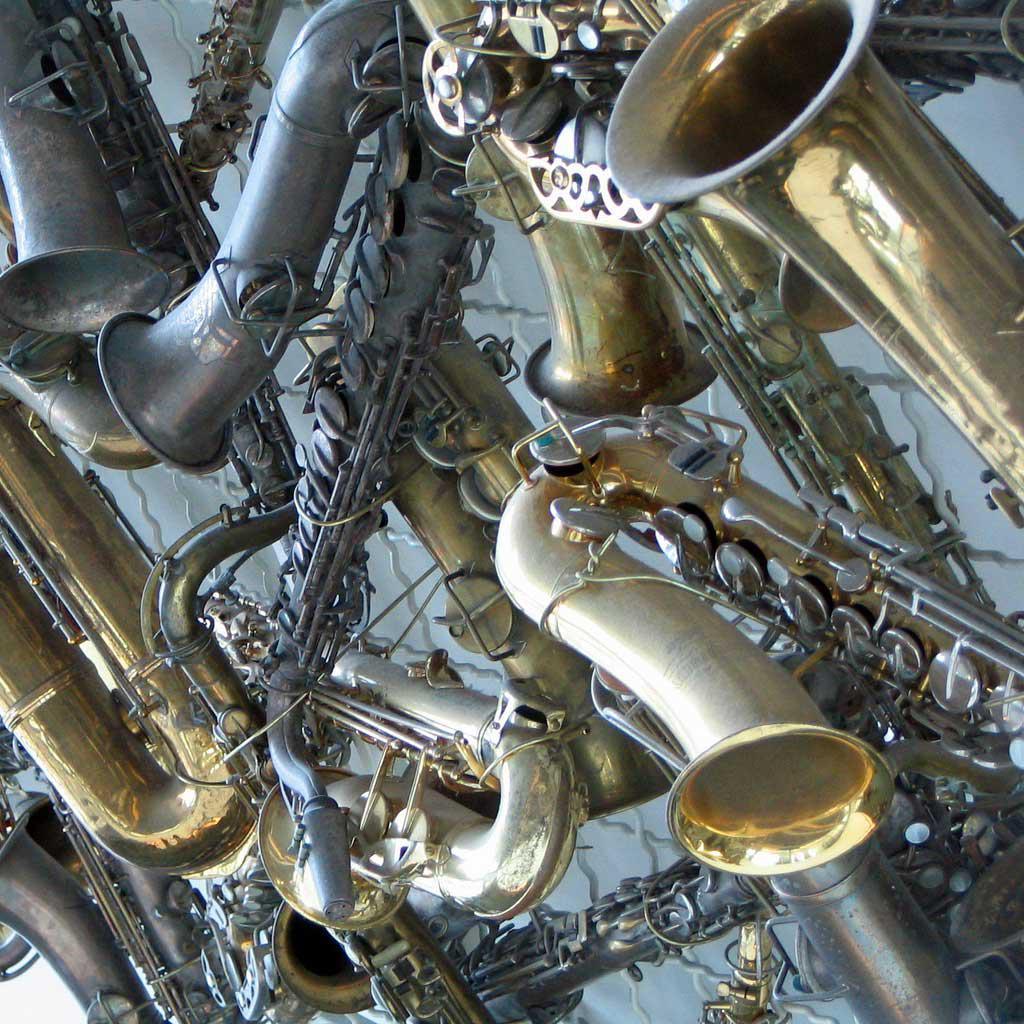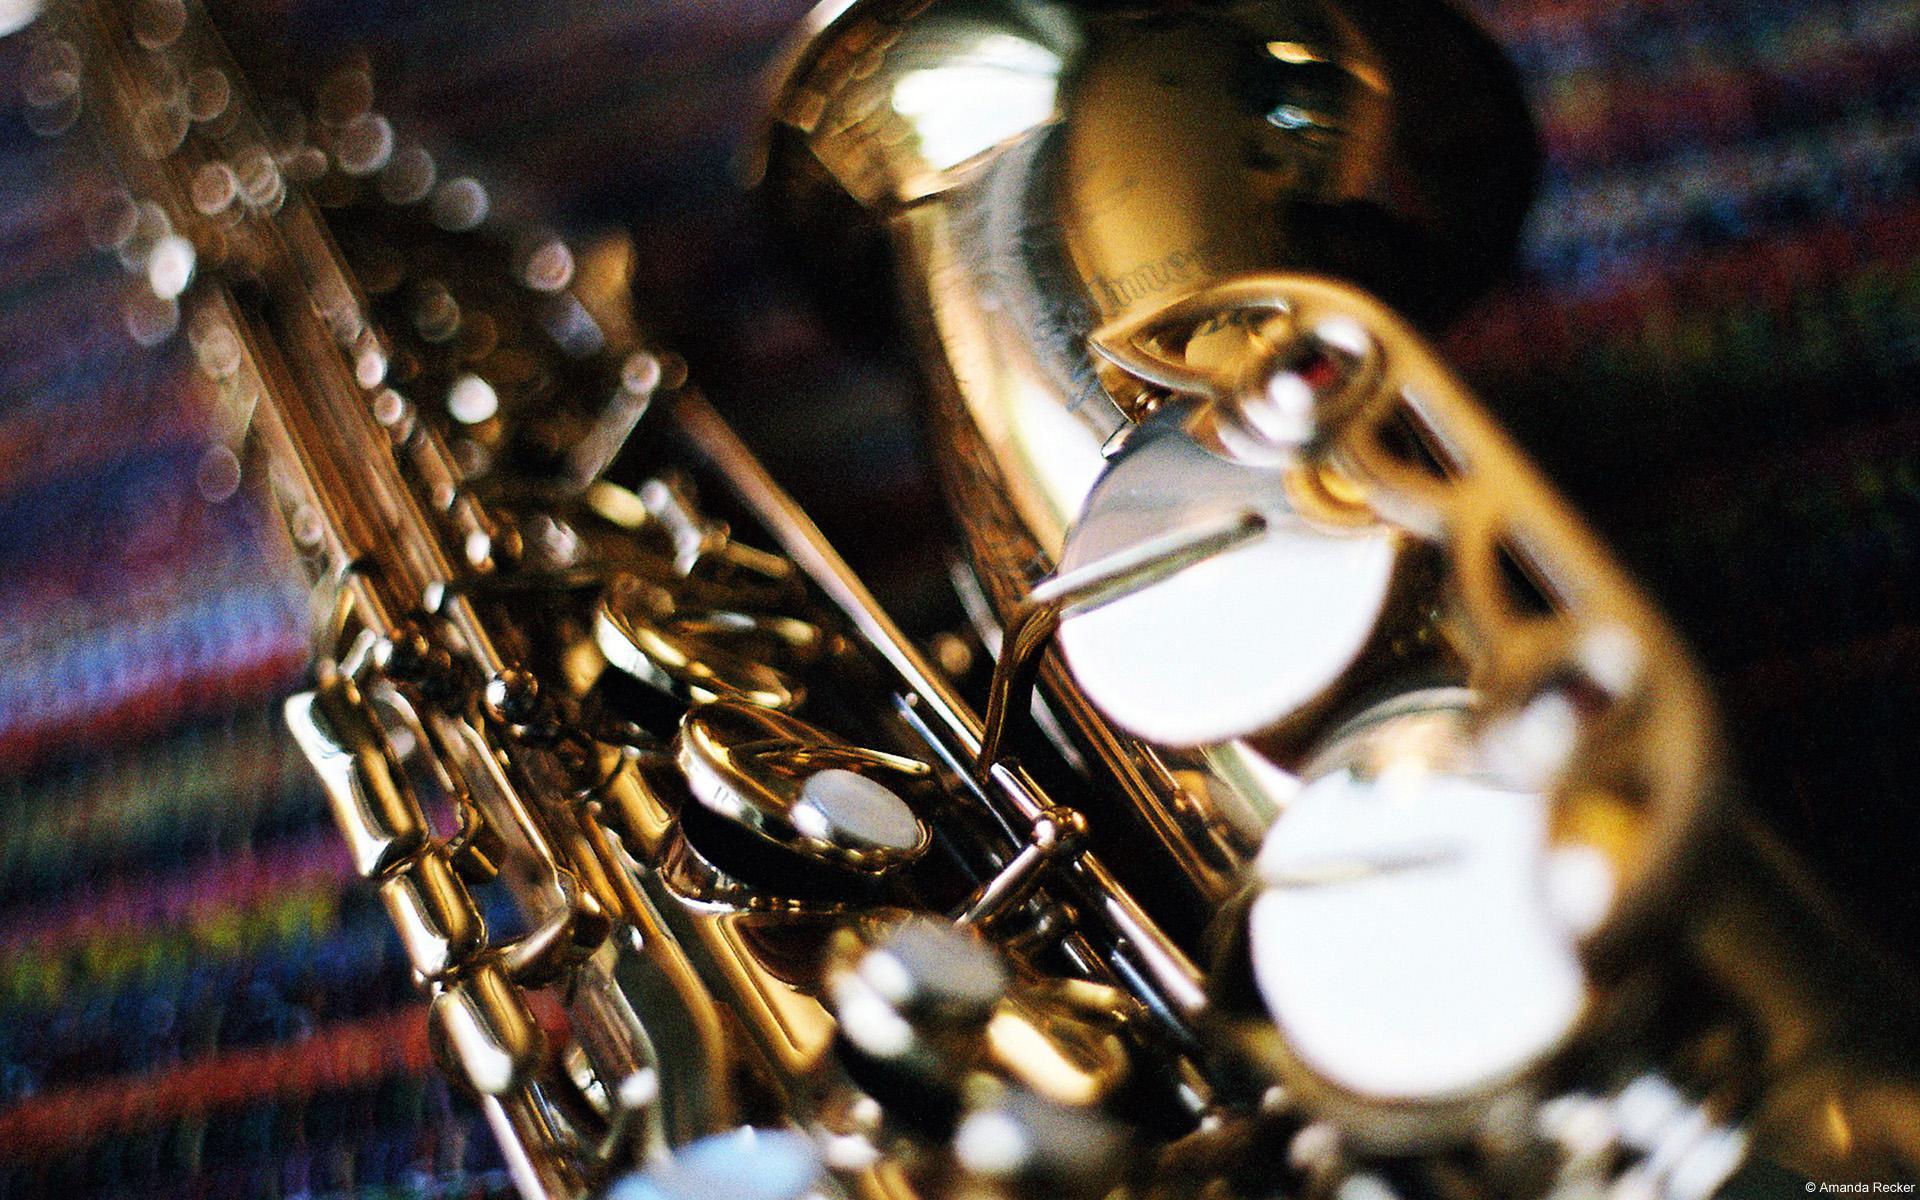The first image is the image on the left, the second image is the image on the right. For the images shown, is this caption "One of the images contains a grouping of at least five saxophones, oriented in a variety of positions." true? Answer yes or no. Yes. The first image is the image on the left, the second image is the image on the right. Given the left and right images, does the statement "One image is in color, while the other is a black and white photo of a person holding a saxophone." hold true? Answer yes or no. No. 